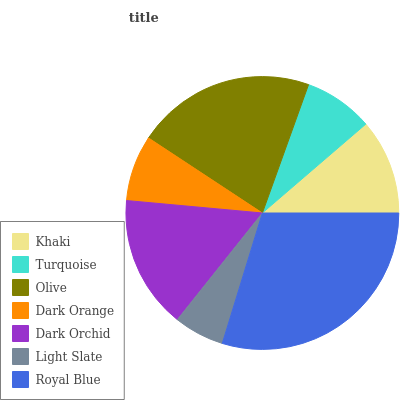Is Light Slate the minimum?
Answer yes or no. Yes. Is Royal Blue the maximum?
Answer yes or no. Yes. Is Turquoise the minimum?
Answer yes or no. No. Is Turquoise the maximum?
Answer yes or no. No. Is Khaki greater than Turquoise?
Answer yes or no. Yes. Is Turquoise less than Khaki?
Answer yes or no. Yes. Is Turquoise greater than Khaki?
Answer yes or no. No. Is Khaki less than Turquoise?
Answer yes or no. No. Is Khaki the high median?
Answer yes or no. Yes. Is Khaki the low median?
Answer yes or no. Yes. Is Olive the high median?
Answer yes or no. No. Is Dark Orange the low median?
Answer yes or no. No. 